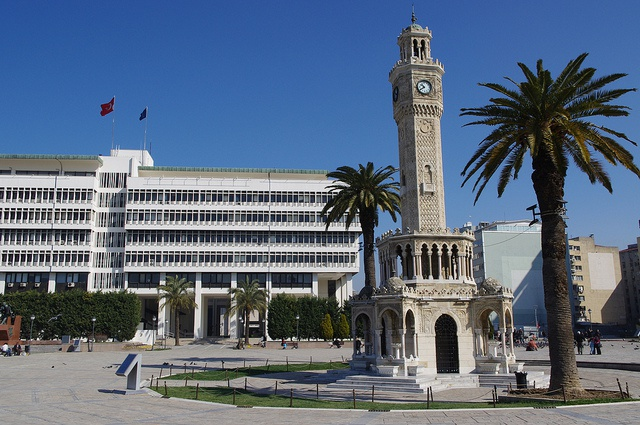Describe the objects in this image and their specific colors. I can see clock in blue, black, darkgray, lightgray, and gray tones, people in blue, black, gray, and purple tones, people in blue, black, gray, maroon, and brown tones, people in blue, black, gray, and darkgray tones, and people in blue, black, purple, and gray tones in this image. 